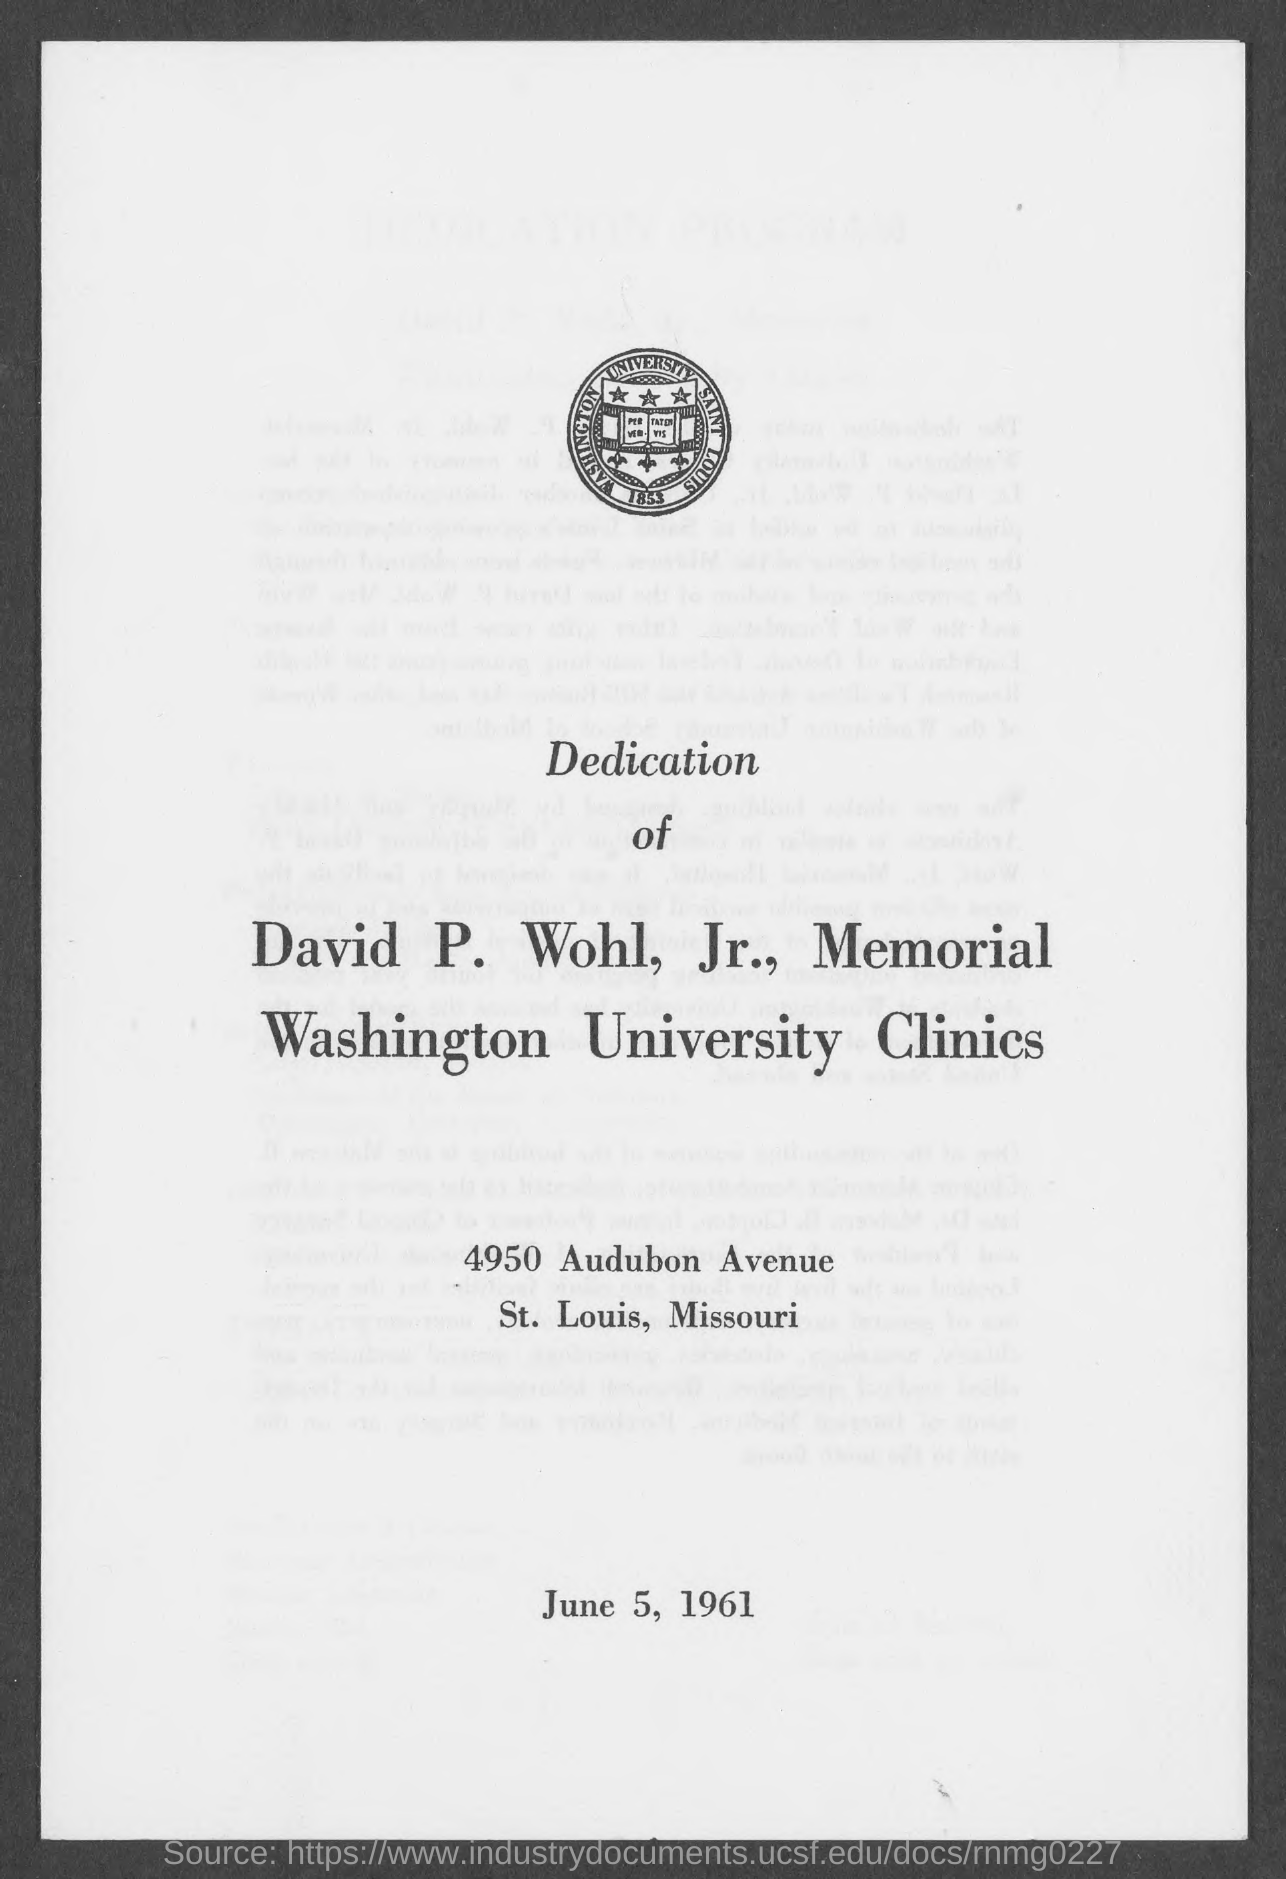Specify some key components in this picture. The given page mentions that the date is June 5, 1961. 